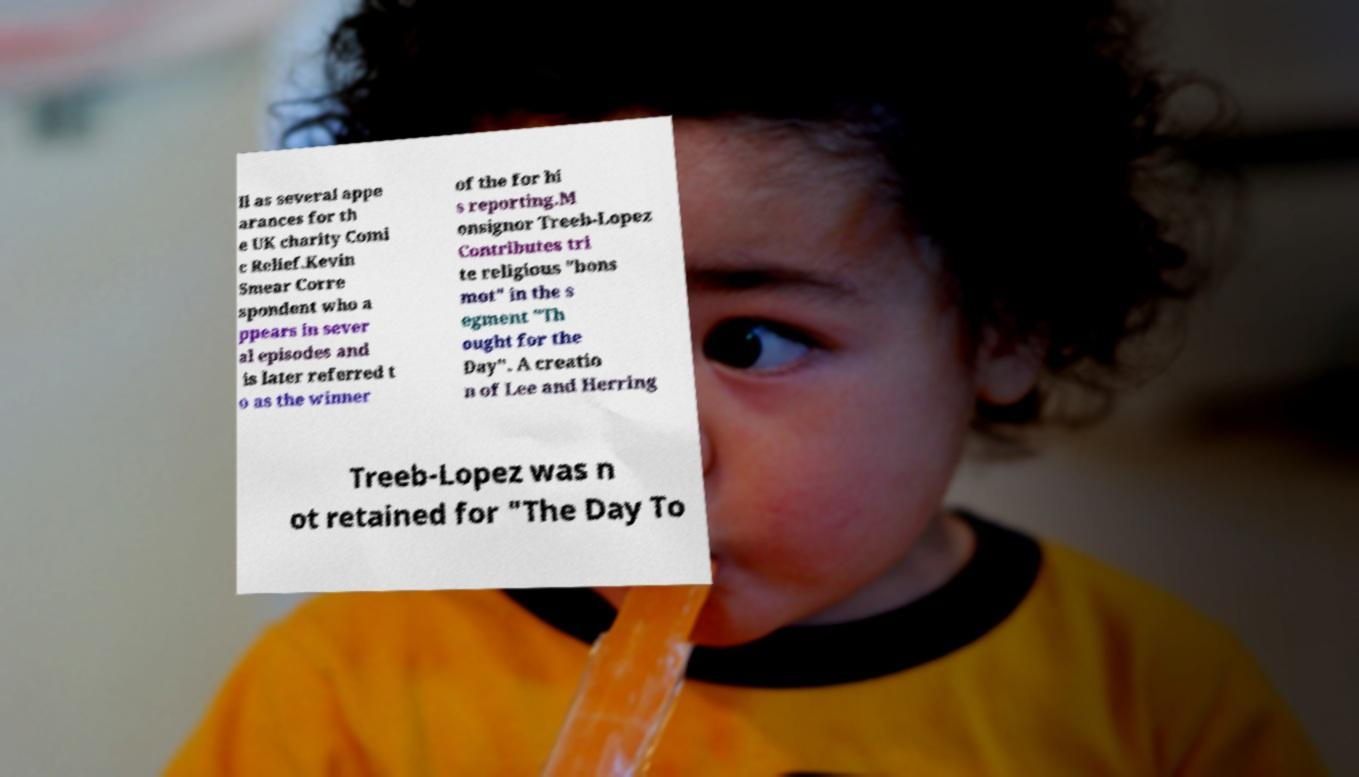For documentation purposes, I need the text within this image transcribed. Could you provide that? ll as several appe arances for th e UK charity Comi c Relief.Kevin Smear Corre spondent who a ppears in sever al episodes and is later referred t o as the winner of the for hi s reporting.M onsignor Treeb-Lopez Contributes tri te religious "bons mot" in the s egment "Th ought for the Day". A creatio n of Lee and Herring Treeb-Lopez was n ot retained for "The Day To 